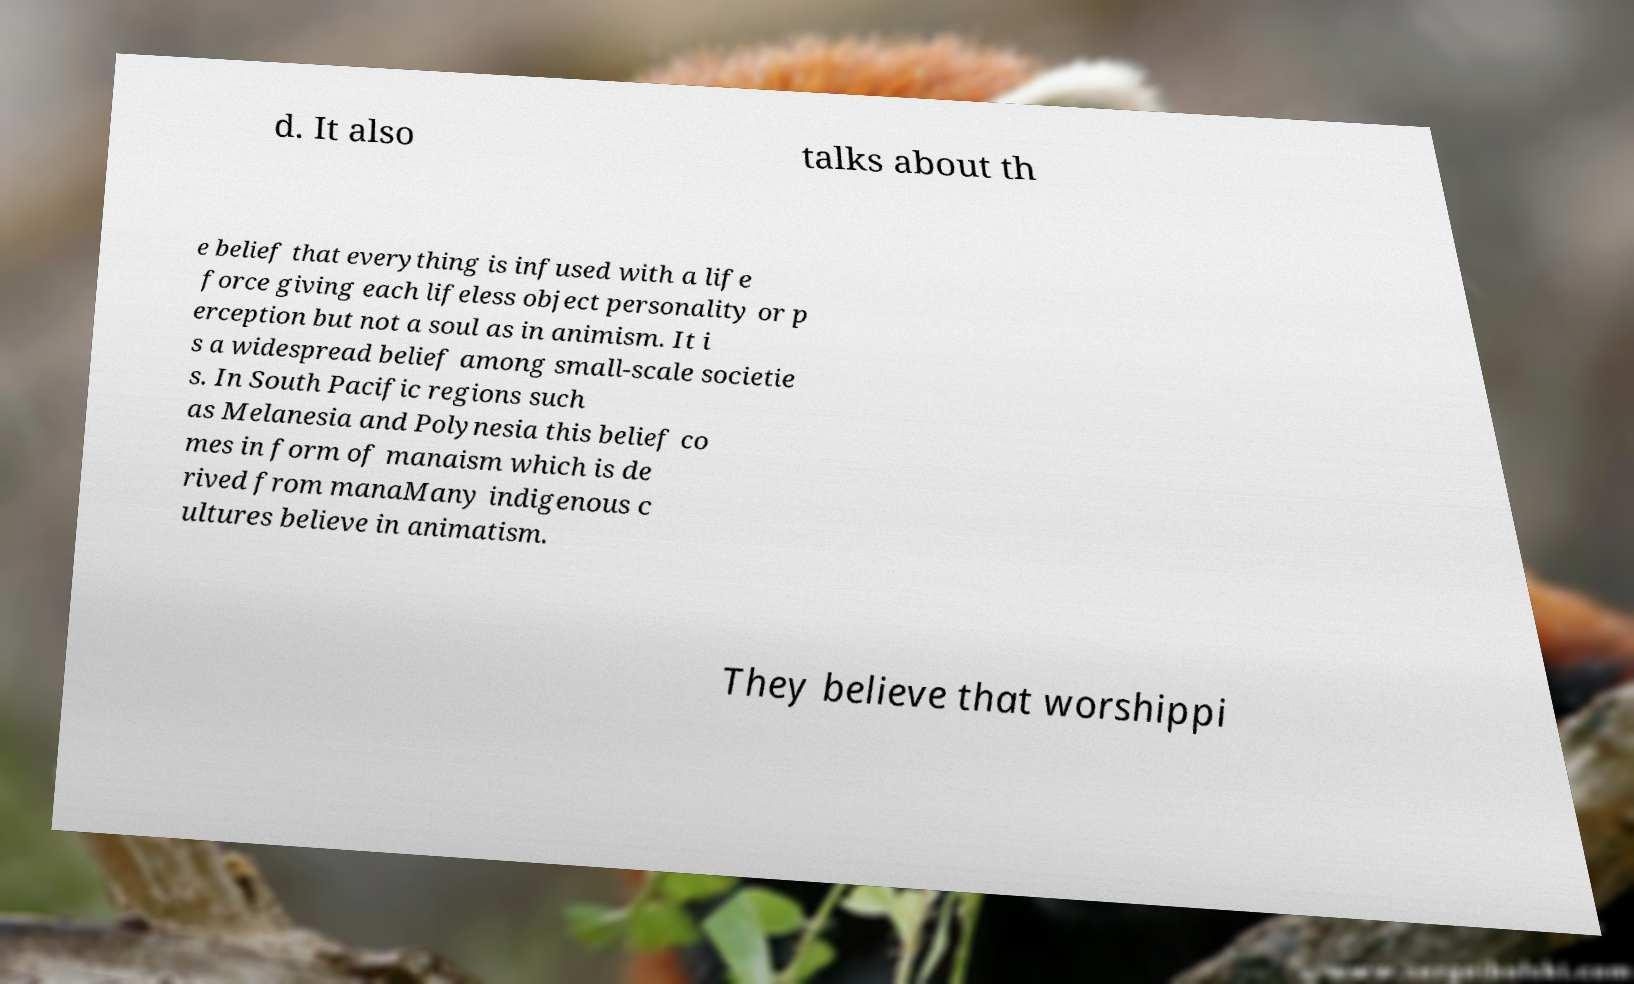I need the written content from this picture converted into text. Can you do that? d. It also talks about th e belief that everything is infused with a life force giving each lifeless object personality or p erception but not a soul as in animism. It i s a widespread belief among small-scale societie s. In South Pacific regions such as Melanesia and Polynesia this belief co mes in form of manaism which is de rived from manaMany indigenous c ultures believe in animatism. They believe that worshippi 